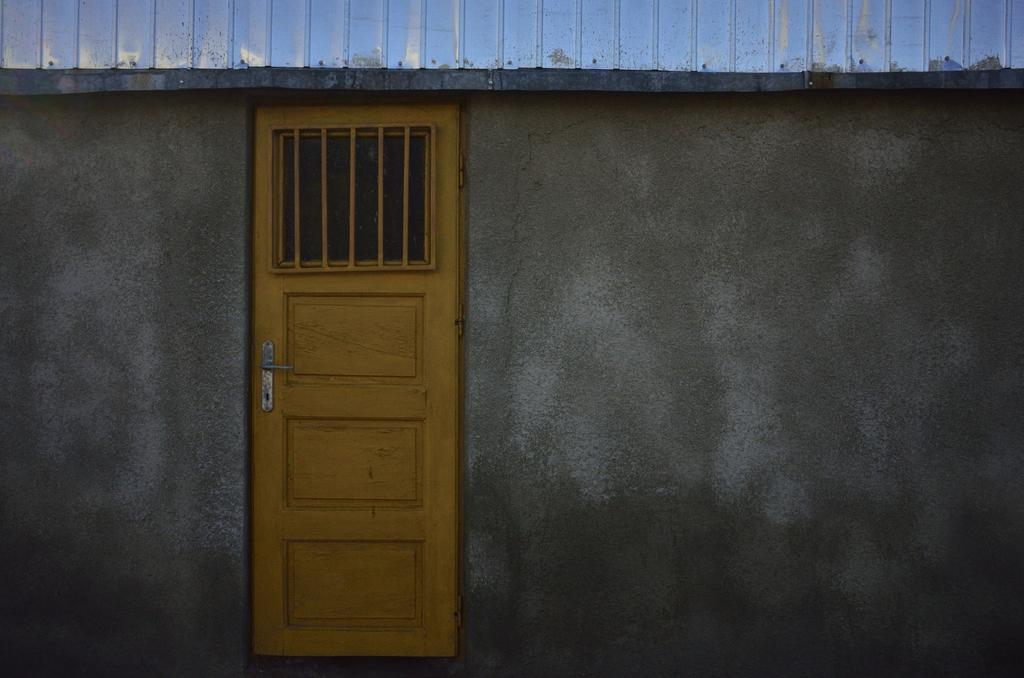What is the main subject in the center of the image? There is a door in the center of the image. What else can be seen in the image? There is a wall in the image. What type of structure might the image depict? The image appears to depict a house. What does the queen believe about the beast in the image? There is no queen or beast present in the image; it only depicts a door and a wall. 